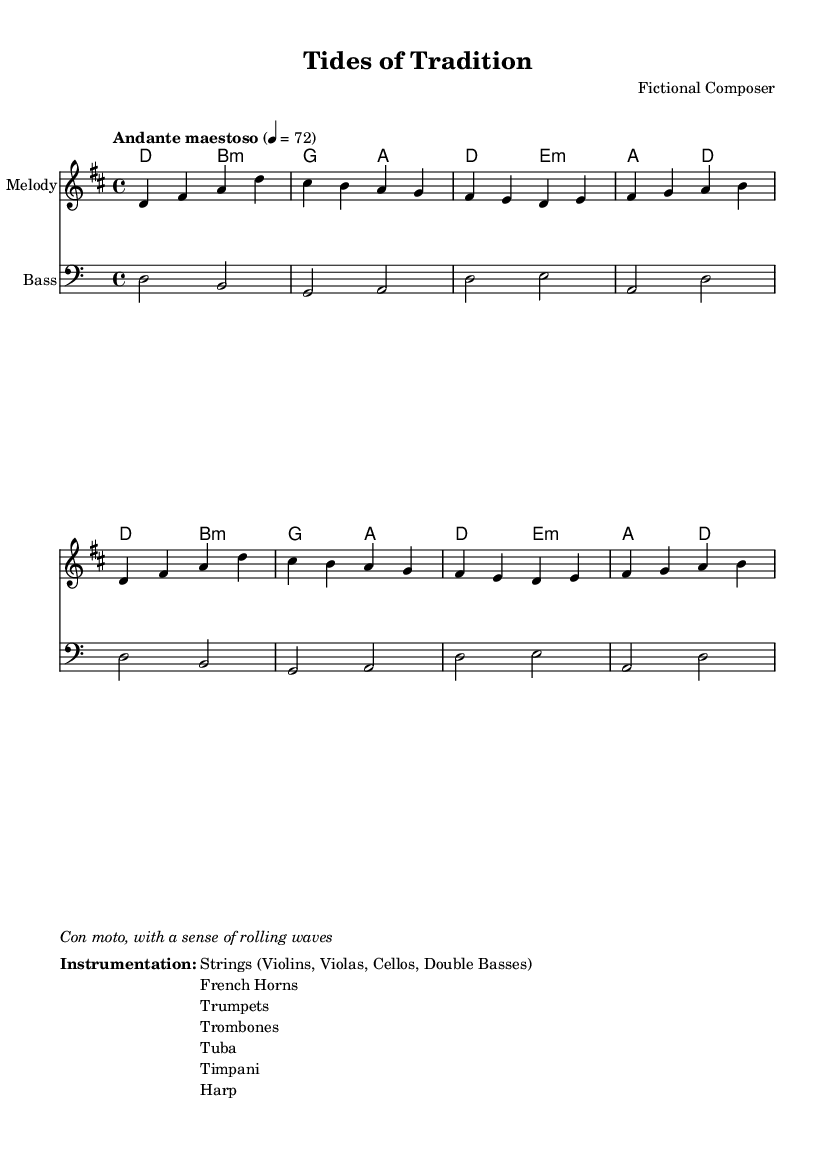What is the key signature of this music? The key signature is indicated by the presence of two sharps (F♯ and C♯) at the beginning of the staff, which signifies D major.
Answer: D major What is the time signature of the piece? The time signature is shown at the beginning of the music and is indicated as 4/4, meaning there are four beats in a measure and a quarter note receives one beat.
Answer: 4/4 What is the tempo marking of this piece? The tempo marking is located above the staff and states "Andante maestoso," which suggests a moderately slow and majestic pace of 72 beats per minute.
Answer: Andante maestoso How many measures are in the melody? By counting the grouped measures in the melody section, there are a total of 8 measures shown in the excerpt.
Answer: 8 measures What instruments are included in the instrumentation? The instrumentation section contains a list of strings, horns, trumpets, trombones, tuba, timpani, and harp, all of which indicate the orchestral makeup for the score.
Answer: Strings, French Horns, Trumpets, Trombones, Tuba, Timpani, Harp Which rhythmic feel is suggested by the instruction "Con moto"? The instruction "Con moto" indicates that the piece should be played with motion or a sense of movement, suggesting an energetic and flowing interpretation.
Answer: A sense of movement 